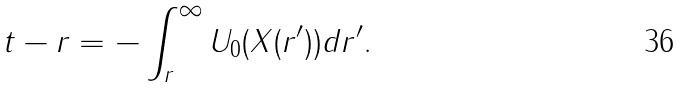<formula> <loc_0><loc_0><loc_500><loc_500>t - r = - \int _ { r } ^ { \infty } U _ { 0 } ( X ( r ^ { \prime } ) ) d r ^ { \prime } .</formula> 